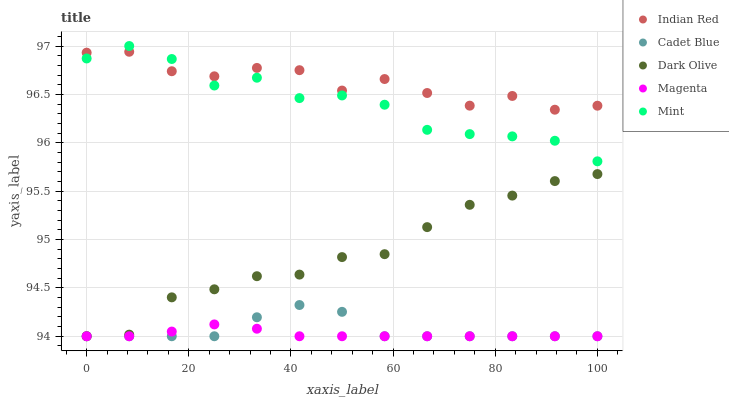Does Magenta have the minimum area under the curve?
Answer yes or no. Yes. Does Indian Red have the maximum area under the curve?
Answer yes or no. Yes. Does Cadet Blue have the minimum area under the curve?
Answer yes or no. No. Does Cadet Blue have the maximum area under the curve?
Answer yes or no. No. Is Magenta the smoothest?
Answer yes or no. Yes. Is Indian Red the roughest?
Answer yes or no. Yes. Is Cadet Blue the smoothest?
Answer yes or no. No. Is Cadet Blue the roughest?
Answer yes or no. No. Does Dark Olive have the lowest value?
Answer yes or no. Yes. Does Mint have the lowest value?
Answer yes or no. No. Does Mint have the highest value?
Answer yes or no. Yes. Does Cadet Blue have the highest value?
Answer yes or no. No. Is Cadet Blue less than Mint?
Answer yes or no. Yes. Is Indian Red greater than Cadet Blue?
Answer yes or no. Yes. Does Dark Olive intersect Magenta?
Answer yes or no. Yes. Is Dark Olive less than Magenta?
Answer yes or no. No. Is Dark Olive greater than Magenta?
Answer yes or no. No. Does Cadet Blue intersect Mint?
Answer yes or no. No. 